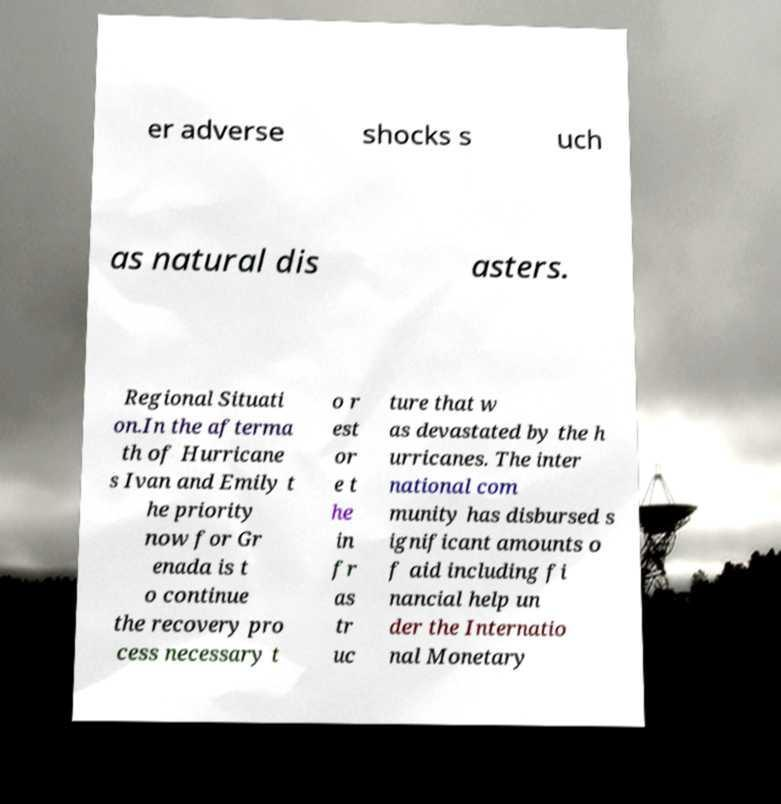Can you accurately transcribe the text from the provided image for me? er adverse shocks s uch as natural dis asters. Regional Situati on.In the afterma th of Hurricane s Ivan and Emily t he priority now for Gr enada is t o continue the recovery pro cess necessary t o r est or e t he in fr as tr uc ture that w as devastated by the h urricanes. The inter national com munity has disbursed s ignificant amounts o f aid including fi nancial help un der the Internatio nal Monetary 